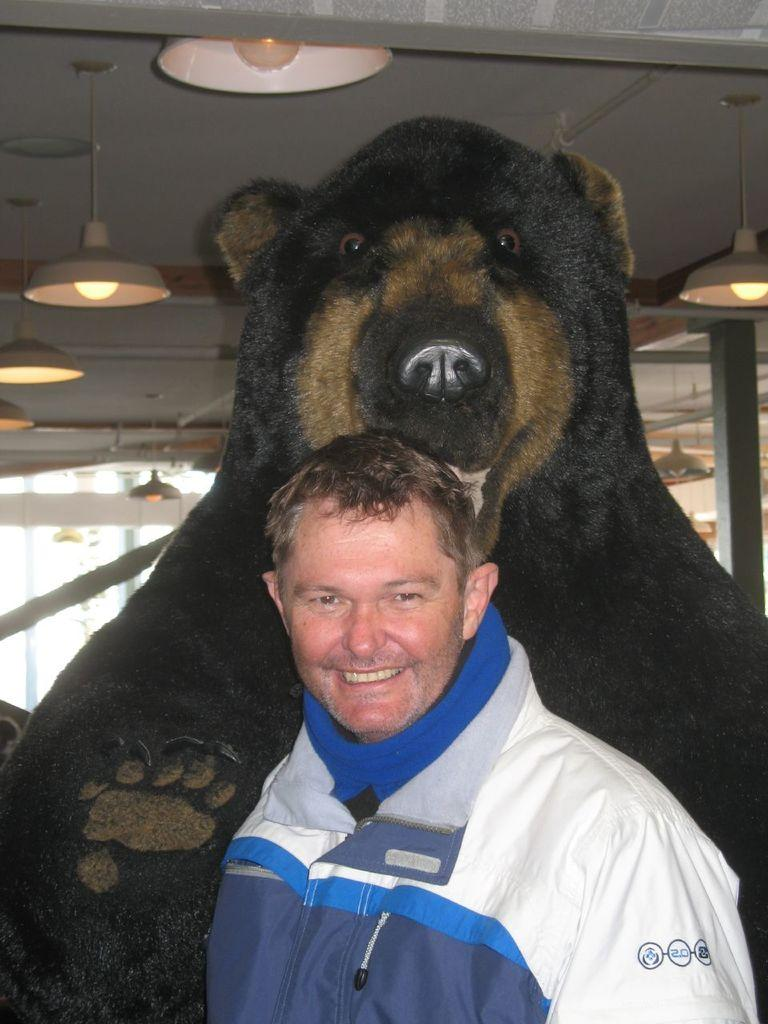Who is the main subject in the foreground of the image? There is a man in the foreground of the image. What object is located behind the man? There is a bear doll behind the man. What can be seen on the roof in the background of the image? There are lights attached to the roof in the background of the image. What type of receipt can be seen in the man's hand in the image? There is no receipt visible in the man's hand in the image. What letters might the man be holding in the image? There are no letters visible in the man's hand in the image. 